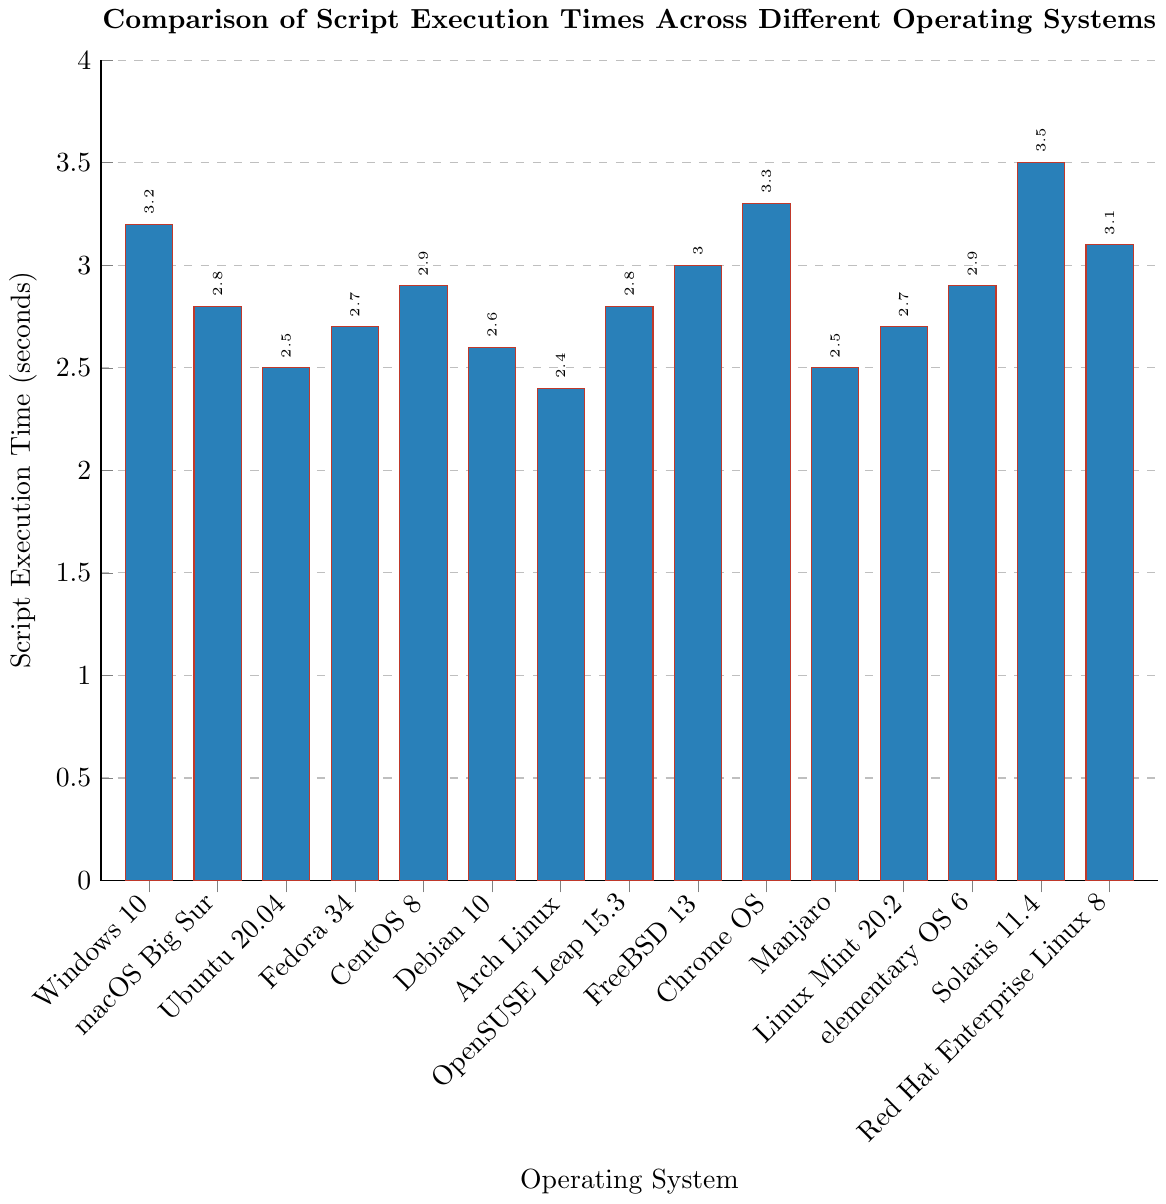what's the shortest script execution time? Look for the shortest bar in the bar chart, which corresponds to Arch Linux with a time of 2.4 seconds
Answer: 2.4 seconds which operating system has the longest script execution time? Find the tallest bar in the chart, representing Solaris 11.4 with a time of 3.5 seconds
Answer: Solaris 11.4 what is the difference in script execution time between Windows 10 and Ubuntu 20.04? Windows 10 has a time of 3.2 seconds, and Ubuntu 20.04 has 2.5 seconds. Calculate the difference: 3.2 - 2.5 = 0.7 seconds
Answer: 0.7 seconds what is the average script execution time of macOS Big Sur, Fedora 34, and CentOS 8? Add the times: 2.8 (macOS Big Sur) + 2.7 (Fedora 34) + 2.9 (CentOS 8) and divide by 3:
\[ \frac{2.8 + 2.7 + 2.9}{3} = 2.8 \]
Answer: 2.8 seconds how many operating systems have script execution times less than 3 seconds? Count the bars with heights less than 3 seconds. These are: macOS Big Sur, Ubuntu 20.04, Fedora 34, Debian 10, Arch Linux, OpenSUSE Leap 15.3, Manjaro, Linux Mint 20.2, elementary OS 6
Answer: 9 which two operating systems have the same script execution time as 2.8 seconds? Identify the bars with heights of 2.8 seconds which are: macOS Big Sur and OpenSUSE Leap 15.3
Answer: macOS Big Sur, OpenSUSE Leap 15.3 is the script execution time for Debian 10 greater or less than Linux Mint 20.2? Find the bars for Debian 10 (2.6 seconds) and Linux Mint 20.2 (2.7 seconds) and compare. Debian 10 is less
Answer: Less what is the combined script execution time for FreeBSD 13 and Chrome OS? Add the times for FreeBSD 13 (3.0 seconds) and Chrome OS (3.3 seconds): 3.0 + 3.3 = 6.3 seconds
Answer: 6.3 seconds what visual element is used to show the operating systems on the x-axis? The operating systems are shown on the x-axis using tick labels
Answer: Tick labels what is the median script execution time across all operating systems? Sort the script execution times and find the middle value for the 15 data points: 2.4, 2.5, 2.5, 2.6, 2.7, 2.7, 2.8, 2.8, 2.9, 2.9, 3.0, 3.1, 3.2, 3.3, 3.5. The 8th value is 2.8
Answer: 2.8 seconds 